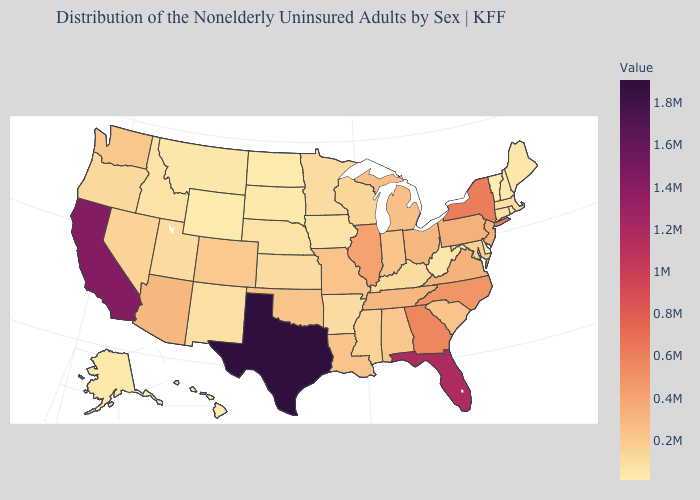Which states hav the highest value in the MidWest?
Quick response, please. Illinois. Does Hawaii have the lowest value in the West?
Be succinct. Yes. Does Wisconsin have the lowest value in the USA?
Write a very short answer. No. Does Vermont have the lowest value in the USA?
Quick response, please. Yes. Does New Hampshire have a higher value than Texas?
Give a very brief answer. No. Which states hav the highest value in the MidWest?
Quick response, please. Illinois. Does West Virginia have the lowest value in the South?
Short answer required. No. 